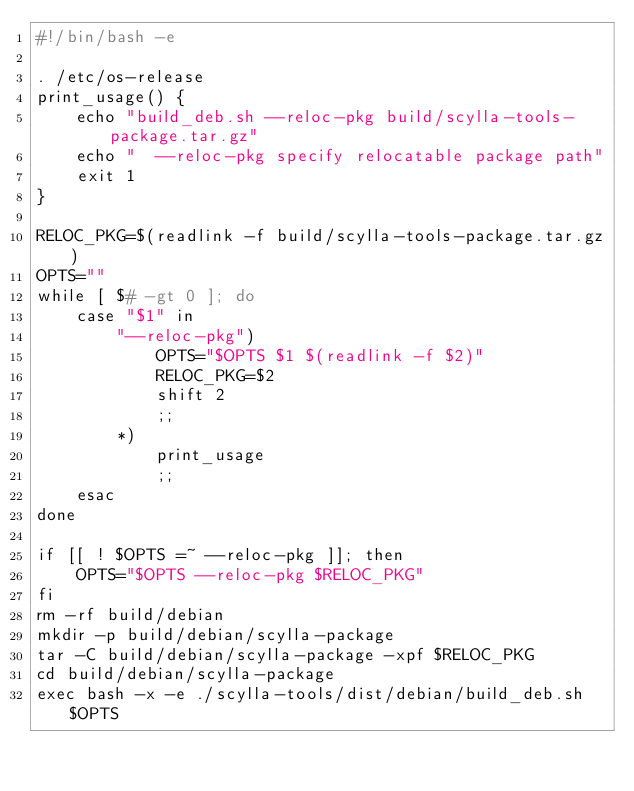Convert code to text. <code><loc_0><loc_0><loc_500><loc_500><_Bash_>#!/bin/bash -e

. /etc/os-release
print_usage() {
    echo "build_deb.sh --reloc-pkg build/scylla-tools-package.tar.gz"
    echo "  --reloc-pkg specify relocatable package path"
    exit 1
}

RELOC_PKG=$(readlink -f build/scylla-tools-package.tar.gz)
OPTS=""
while [ $# -gt 0 ]; do
    case "$1" in
        "--reloc-pkg")
            OPTS="$OPTS $1 $(readlink -f $2)"
            RELOC_PKG=$2
            shift 2
            ;;
        *)
            print_usage
            ;;
    esac
done

if [[ ! $OPTS =~ --reloc-pkg ]]; then
    OPTS="$OPTS --reloc-pkg $RELOC_PKG"
fi
rm -rf build/debian
mkdir -p build/debian/scylla-package
tar -C build/debian/scylla-package -xpf $RELOC_PKG
cd build/debian/scylla-package
exec bash -x -e ./scylla-tools/dist/debian/build_deb.sh $OPTS
</code> 